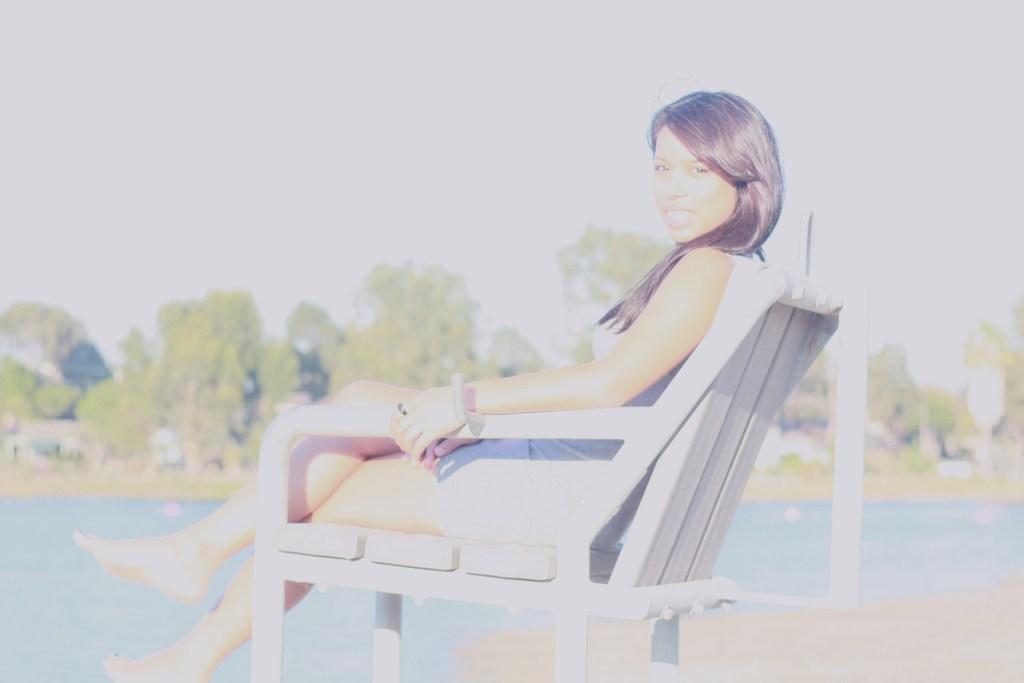In one or two sentences, can you explain what this image depicts? In this image we can see a woman is sitting on the chair. At the background we can see water,trees and a sky. 